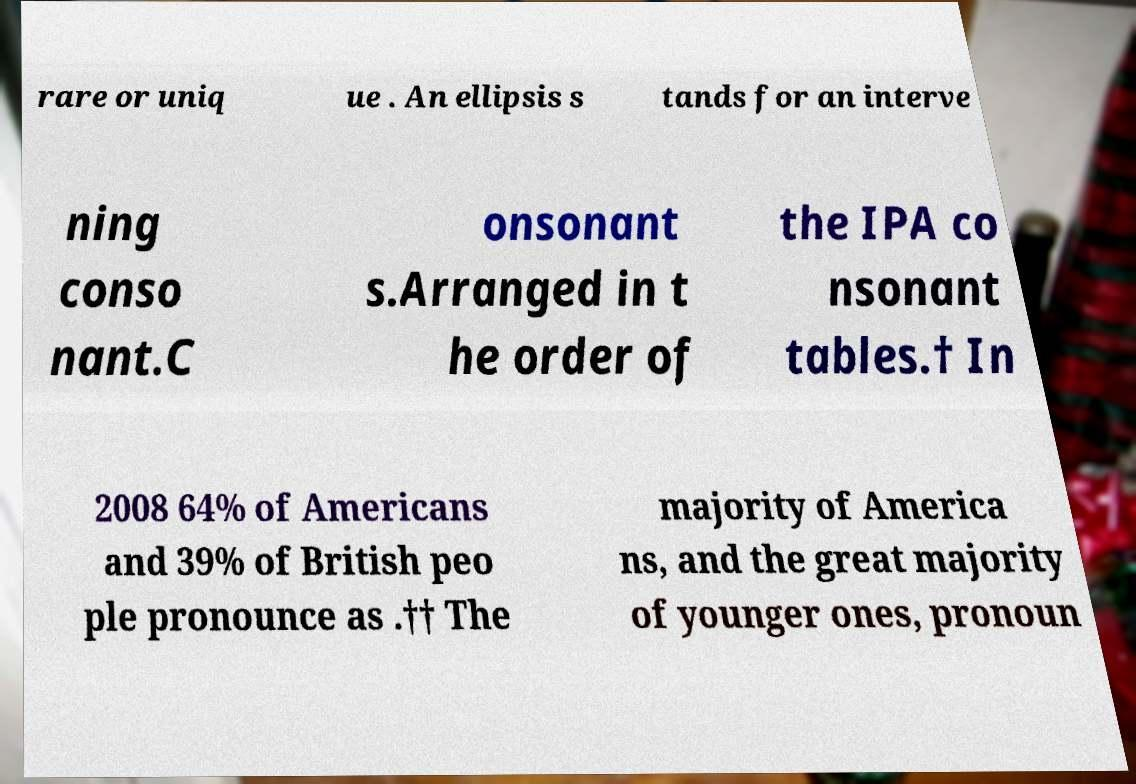Could you assist in decoding the text presented in this image and type it out clearly? rare or uniq ue . An ellipsis s tands for an interve ning conso nant.C onsonant s.Arranged in t he order of the IPA co nsonant tables.† In 2008 64% of Americans and 39% of British peo ple pronounce as .†† The majority of America ns, and the great majority of younger ones, pronoun 